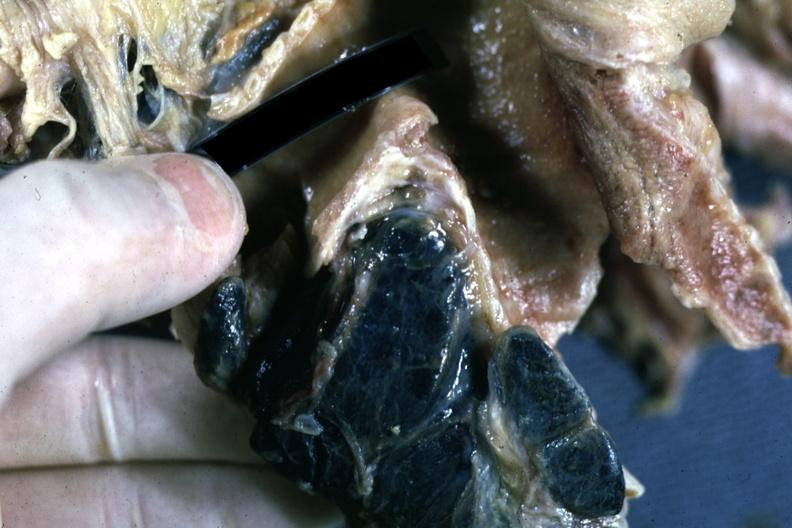does peritoneum show fixed tissue sectioned carinal nodes shown close-up nodes are filled with black pigment?
Answer the question using a single word or phrase. No 